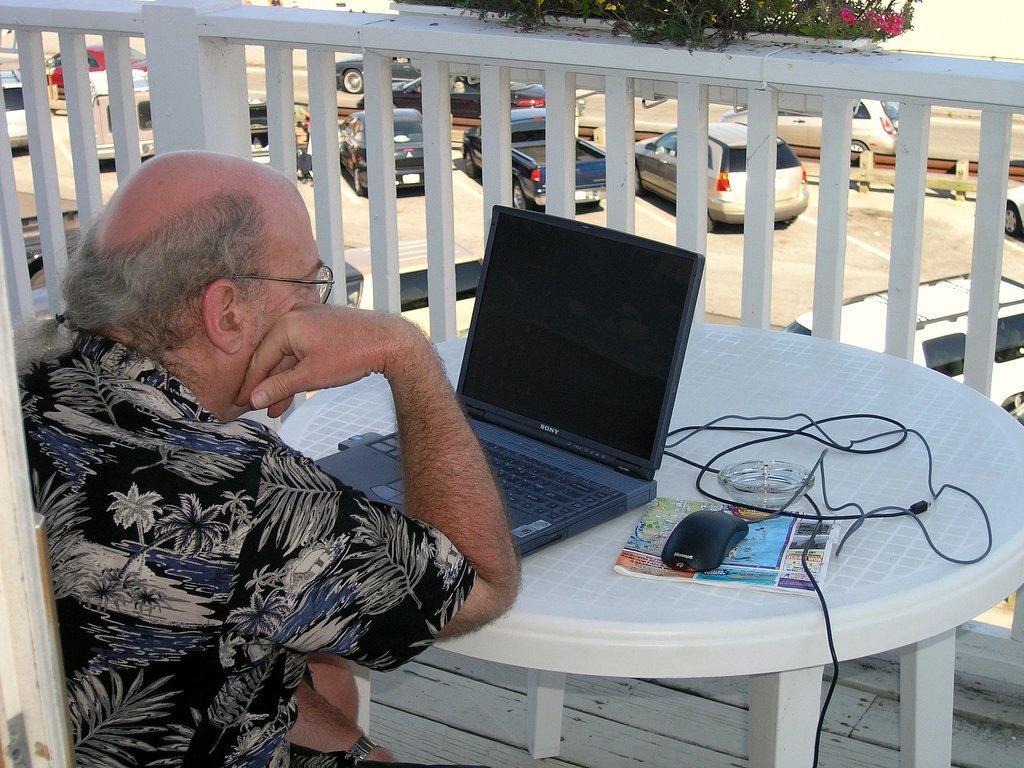Please provide a concise description of this image. In the foreground of this image, there is a man sitting in front of a table on which a laptop, mouse, book and a bowl is placed. In the background, there is a railing, few plants and behind it, there are few vehicles moving in the road. 